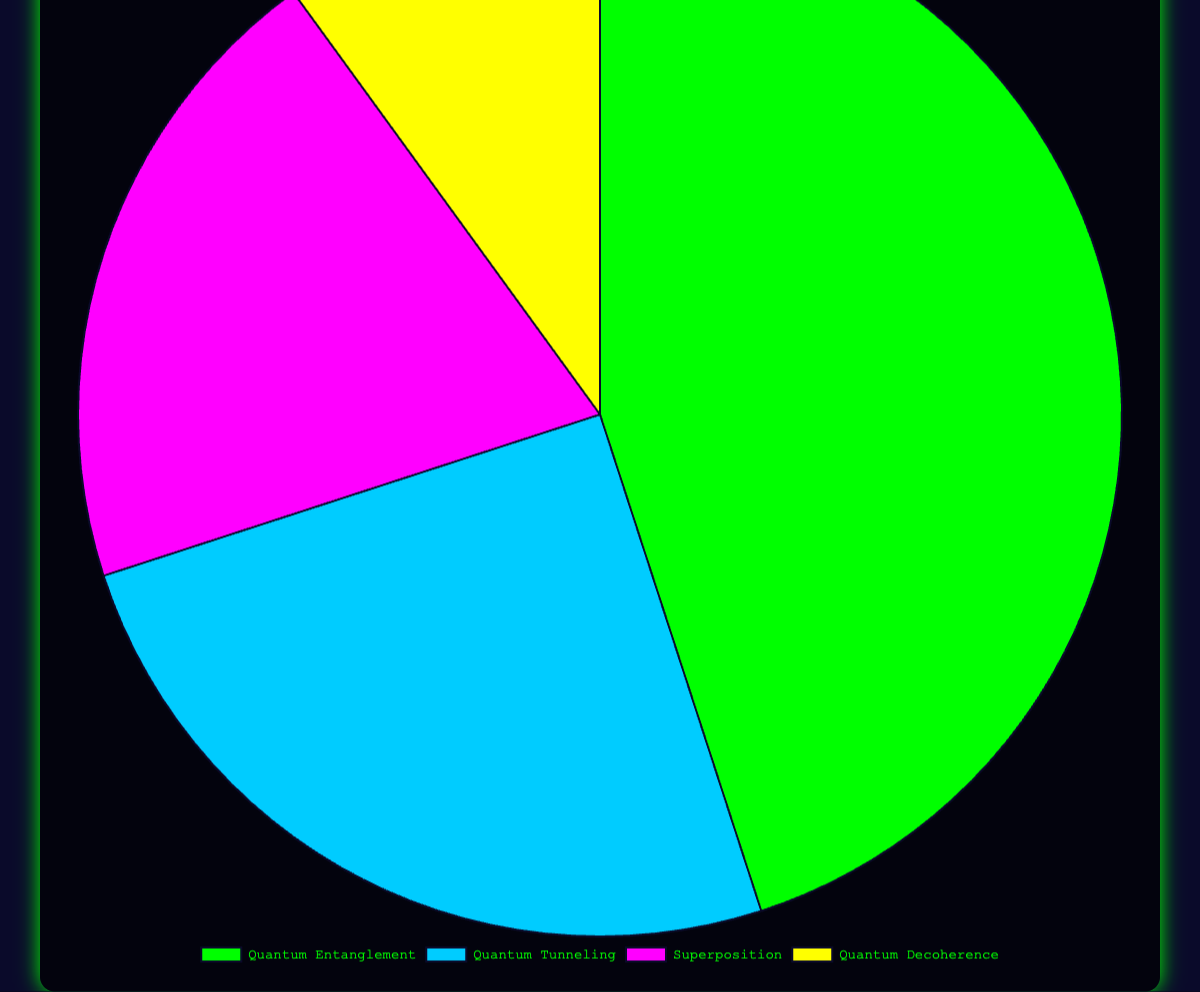Which concept is represented the most in popular science fiction works? By looking at the size of the pie slices, Quantum Entanglement is represented the most with 45 occurrences.
Answer: Quantum Entanglement Which concept has the smallest representation? The smallest slice in the pie chart represents Quantum Decoherence with 10 occurrences.
Answer: Quantum Decoherence Which two concepts combined have the highest occurrence? By summing the counts of Quantum Entanglement (45) and Quantum Tunneling (25), we get 70, which is higher than any other combination.
Answer: Quantum Entanglement and Quantum Tunneling What is the total number of occurrences of Superposition and Quantum Decoherence? Adding the counts of Superposition (20) and Quantum Decoherence (10) gives us 30.
Answer: 30 How many more occurrences does Quantum Entanglement have compared to Superposition? The difference between Quantum Entanglement (45) and Superposition (20) is 25.
Answer: 25 If you combine Quantum Tunneling and Superposition, will the total exceed Quantum Entanglement? Adding Quantum Tunneling (25) and Superposition (20) gives us 45, which is equal to the count of Quantum Entanglement.
Answer: No What is the visual color representation of Quantum Tunneling in the chart? Based on the legend and pie colors, Quantum Tunneling is represented in blue.
Answer: Blue What percentage of the total occurrences does Quantum Decoherence represent? There are 100 total occurrences (45 + 25 + 20 + 10). Quantum Decoherence represents 10 out of 100, so 10%.
Answer: 10% How much larger is the representation of Quantum Tunneling compared to Quantum Decoherence? Subtracting Quantum Decoherence's count (10) from Quantum Tunneling's count (25) gives 15.
Answer: 15 Which concept has less representation, Quantum Entanglement or Superposition? By comparing their counts, Quantum Entanglement (45) has more representation, so Superposition (20) has less.
Answer: Superposition 